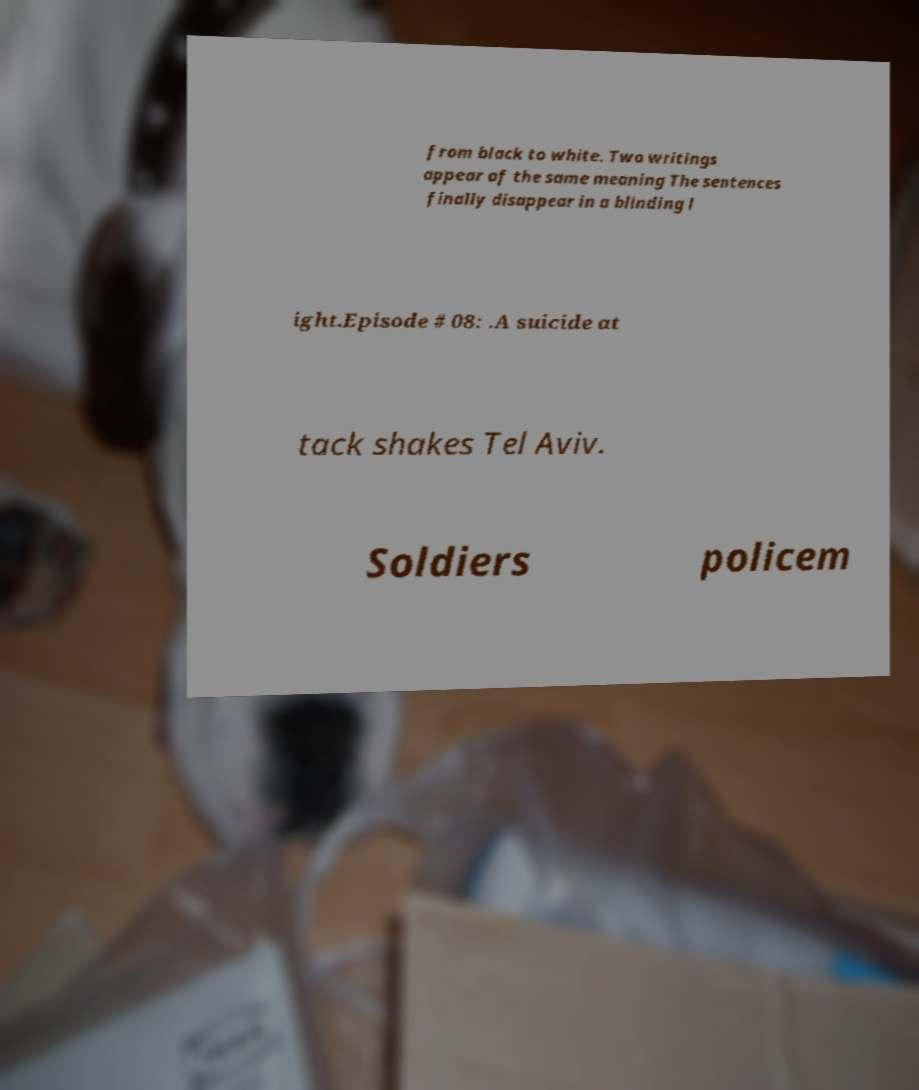There's text embedded in this image that I need extracted. Can you transcribe it verbatim? from black to white. Two writings appear of the same meaning The sentences finally disappear in a blinding l ight.Episode # 08: .A suicide at tack shakes Tel Aviv. Soldiers policem 